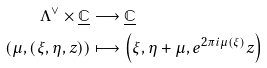Convert formula to latex. <formula><loc_0><loc_0><loc_500><loc_500>\Lambda ^ { \vee } \times \underline { \mathbb { C } } & \longrightarrow \underline { \mathbb { C } } \\ \left ( \mu , \left ( \xi , \eta , z \right ) \right ) & \longmapsto \left ( \xi , \eta + \mu , e ^ { 2 \pi i \mu ( \xi ) } z \right )</formula> 